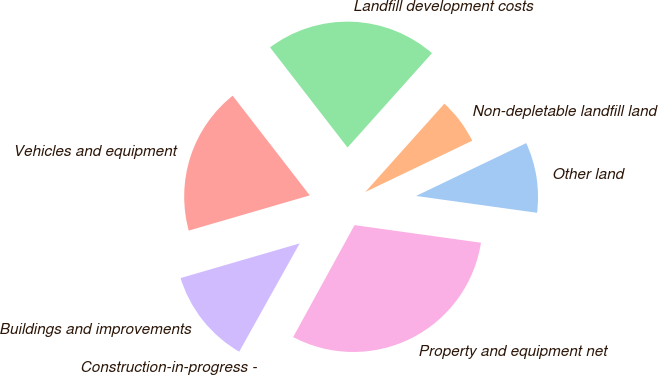Convert chart. <chart><loc_0><loc_0><loc_500><loc_500><pie_chart><fcel>Other land<fcel>Non-depletable landfill land<fcel>Landfill development costs<fcel>Vehicles and equipment<fcel>Buildings and improvements<fcel>Construction-in-progress -<fcel>Property and equipment net<nl><fcel>9.32%<fcel>6.26%<fcel>22.1%<fcel>19.03%<fcel>12.39%<fcel>0.12%<fcel>30.78%<nl></chart> 